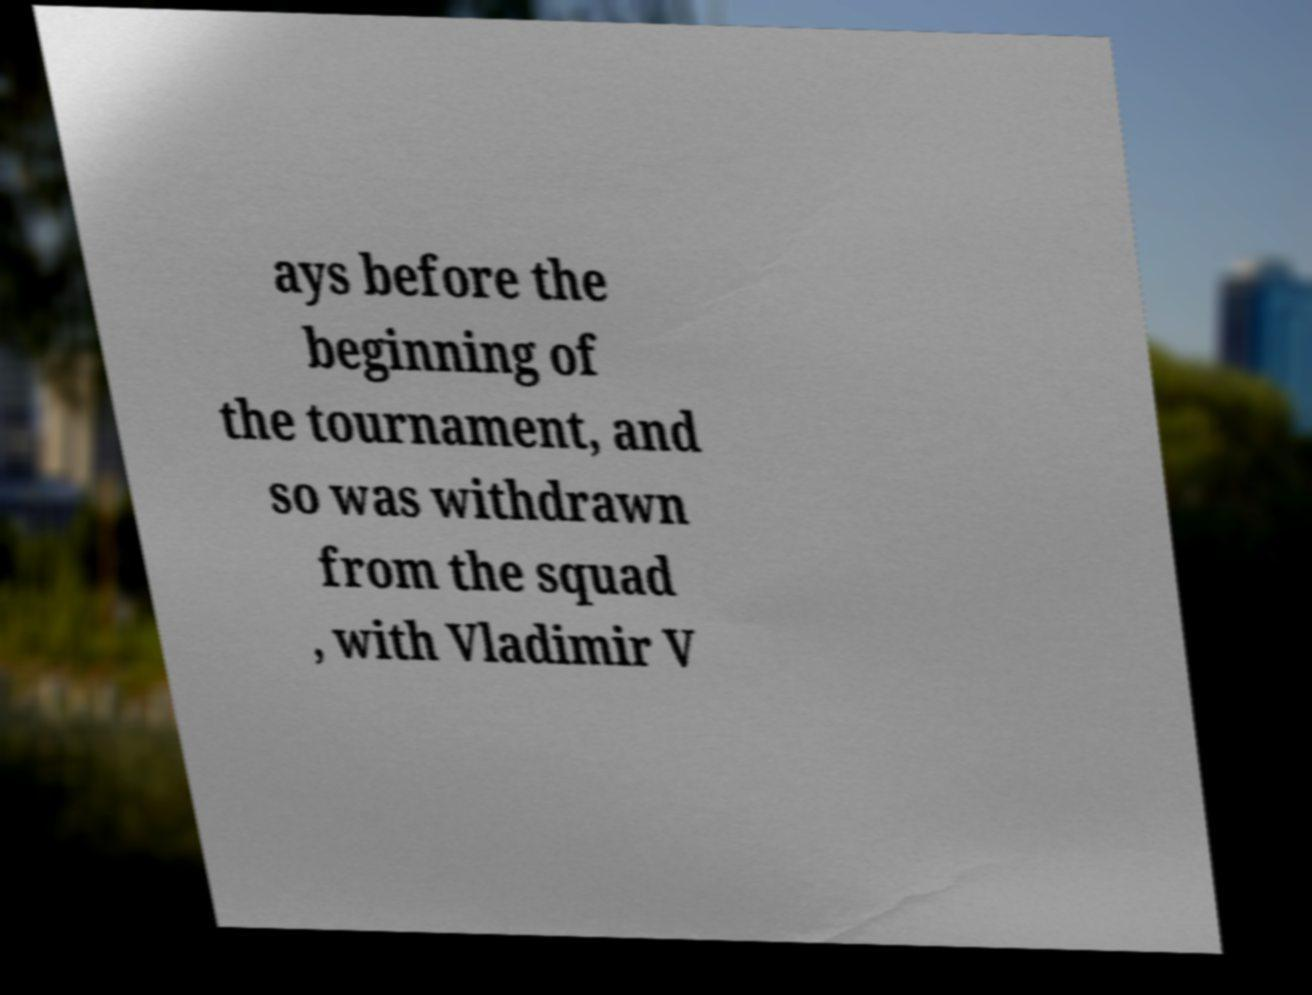Please read and relay the text visible in this image. What does it say? ays before the beginning of the tournament, and so was withdrawn from the squad , with Vladimir V 